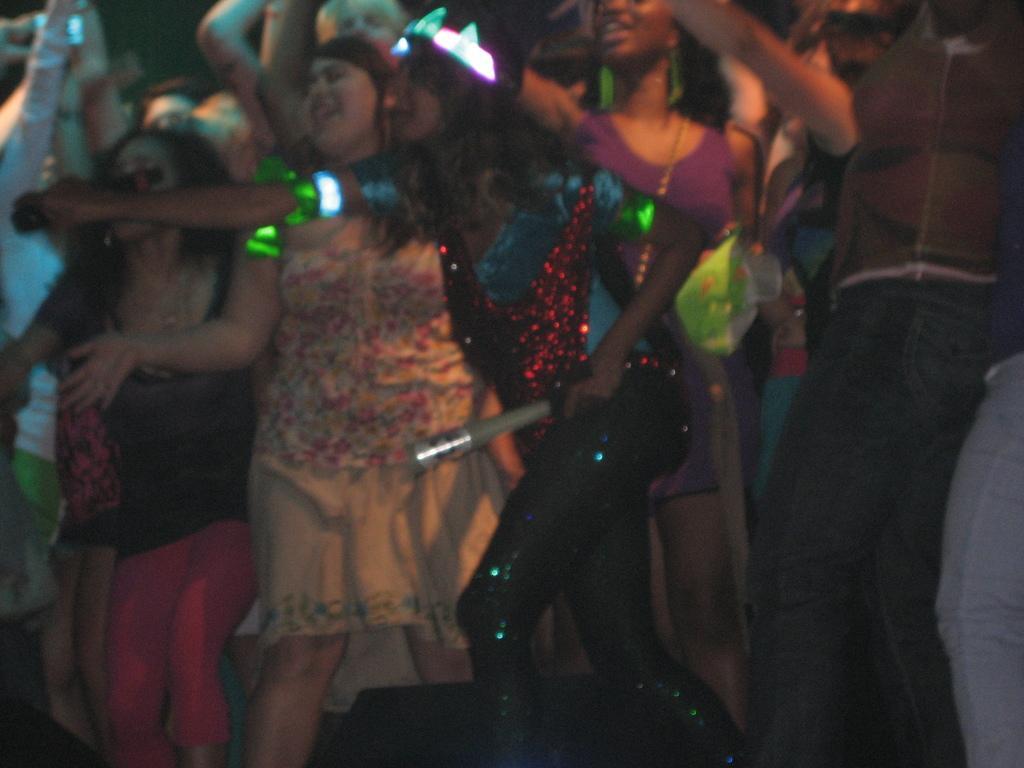Please provide a concise description of this image. In this picture there are people in the center of the image, they are dancing. 